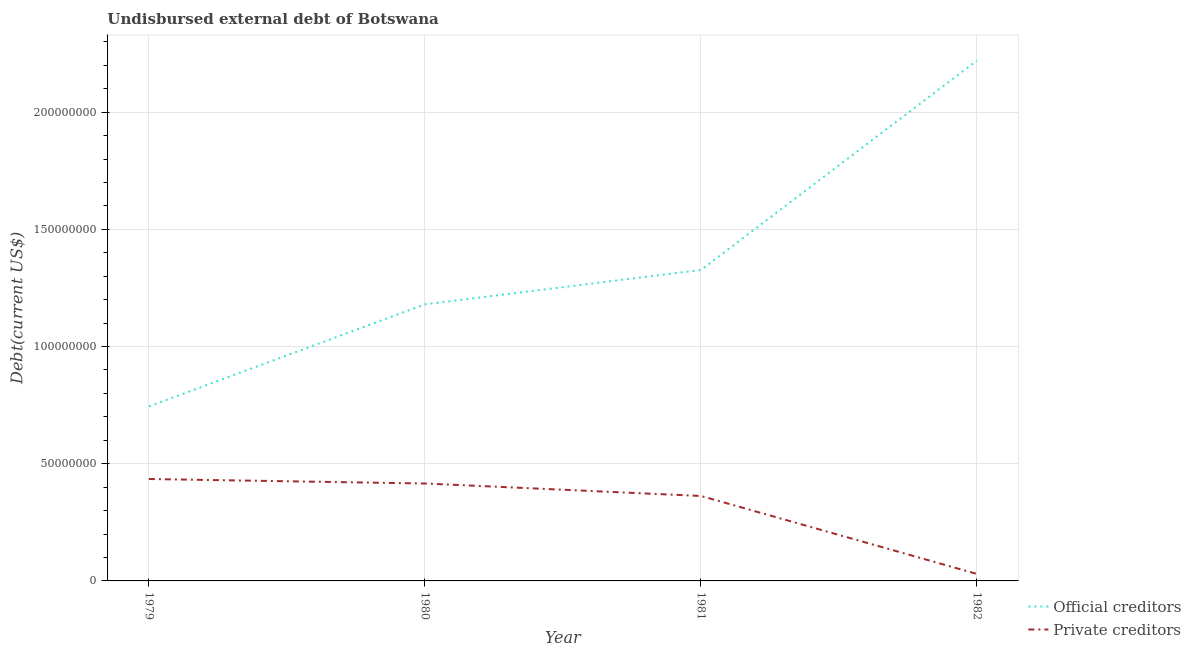Is the number of lines equal to the number of legend labels?
Your answer should be very brief. Yes. What is the undisbursed external debt of private creditors in 1981?
Ensure brevity in your answer.  3.62e+07. Across all years, what is the maximum undisbursed external debt of private creditors?
Provide a succinct answer. 4.35e+07. Across all years, what is the minimum undisbursed external debt of official creditors?
Your response must be concise. 7.44e+07. In which year was the undisbursed external debt of official creditors maximum?
Provide a short and direct response. 1982. In which year was the undisbursed external debt of private creditors minimum?
Provide a succinct answer. 1982. What is the total undisbursed external debt of private creditors in the graph?
Your response must be concise. 1.24e+08. What is the difference between the undisbursed external debt of official creditors in 1980 and that in 1982?
Keep it short and to the point. -1.04e+08. What is the difference between the undisbursed external debt of private creditors in 1979 and the undisbursed external debt of official creditors in 1980?
Make the answer very short. -7.45e+07. What is the average undisbursed external debt of official creditors per year?
Give a very brief answer. 1.37e+08. In the year 1979, what is the difference between the undisbursed external debt of private creditors and undisbursed external debt of official creditors?
Provide a succinct answer. -3.10e+07. In how many years, is the undisbursed external debt of official creditors greater than 210000000 US$?
Make the answer very short. 1. What is the ratio of the undisbursed external debt of official creditors in 1980 to that in 1982?
Your response must be concise. 0.53. Is the difference between the undisbursed external debt of private creditors in 1979 and 1980 greater than the difference between the undisbursed external debt of official creditors in 1979 and 1980?
Ensure brevity in your answer.  Yes. What is the difference between the highest and the second highest undisbursed external debt of official creditors?
Your answer should be very brief. 8.94e+07. What is the difference between the highest and the lowest undisbursed external debt of private creditors?
Provide a succinct answer. 4.05e+07. In how many years, is the undisbursed external debt of private creditors greater than the average undisbursed external debt of private creditors taken over all years?
Keep it short and to the point. 3. Is the sum of the undisbursed external debt of official creditors in 1981 and 1982 greater than the maximum undisbursed external debt of private creditors across all years?
Ensure brevity in your answer.  Yes. Does the undisbursed external debt of official creditors monotonically increase over the years?
Your answer should be compact. Yes. How many years are there in the graph?
Offer a terse response. 4. What is the difference between two consecutive major ticks on the Y-axis?
Your answer should be compact. 5.00e+07. Does the graph contain any zero values?
Offer a very short reply. No. How many legend labels are there?
Make the answer very short. 2. How are the legend labels stacked?
Provide a succinct answer. Vertical. What is the title of the graph?
Offer a very short reply. Undisbursed external debt of Botswana. Does "Number of departures" appear as one of the legend labels in the graph?
Your answer should be very brief. No. What is the label or title of the X-axis?
Offer a very short reply. Year. What is the label or title of the Y-axis?
Offer a very short reply. Debt(current US$). What is the Debt(current US$) of Official creditors in 1979?
Your answer should be compact. 7.44e+07. What is the Debt(current US$) in Private creditors in 1979?
Provide a succinct answer. 4.35e+07. What is the Debt(current US$) of Official creditors in 1980?
Your answer should be very brief. 1.18e+08. What is the Debt(current US$) in Private creditors in 1980?
Keep it short and to the point. 4.16e+07. What is the Debt(current US$) in Official creditors in 1981?
Offer a terse response. 1.33e+08. What is the Debt(current US$) of Private creditors in 1981?
Your answer should be compact. 3.62e+07. What is the Debt(current US$) in Official creditors in 1982?
Make the answer very short. 2.22e+08. What is the Debt(current US$) of Private creditors in 1982?
Your answer should be compact. 2.98e+06. Across all years, what is the maximum Debt(current US$) of Official creditors?
Give a very brief answer. 2.22e+08. Across all years, what is the maximum Debt(current US$) in Private creditors?
Provide a succinct answer. 4.35e+07. Across all years, what is the minimum Debt(current US$) of Official creditors?
Keep it short and to the point. 7.44e+07. Across all years, what is the minimum Debt(current US$) of Private creditors?
Make the answer very short. 2.98e+06. What is the total Debt(current US$) of Official creditors in the graph?
Ensure brevity in your answer.  5.47e+08. What is the total Debt(current US$) in Private creditors in the graph?
Provide a succinct answer. 1.24e+08. What is the difference between the Debt(current US$) of Official creditors in 1979 and that in 1980?
Provide a short and direct response. -4.36e+07. What is the difference between the Debt(current US$) of Private creditors in 1979 and that in 1980?
Make the answer very short. 1.92e+06. What is the difference between the Debt(current US$) in Official creditors in 1979 and that in 1981?
Ensure brevity in your answer.  -5.82e+07. What is the difference between the Debt(current US$) in Private creditors in 1979 and that in 1981?
Provide a short and direct response. 7.23e+06. What is the difference between the Debt(current US$) of Official creditors in 1979 and that in 1982?
Give a very brief answer. -1.48e+08. What is the difference between the Debt(current US$) in Private creditors in 1979 and that in 1982?
Provide a short and direct response. 4.05e+07. What is the difference between the Debt(current US$) of Official creditors in 1980 and that in 1981?
Give a very brief answer. -1.46e+07. What is the difference between the Debt(current US$) in Private creditors in 1980 and that in 1981?
Provide a succinct answer. 5.32e+06. What is the difference between the Debt(current US$) of Official creditors in 1980 and that in 1982?
Make the answer very short. -1.04e+08. What is the difference between the Debt(current US$) in Private creditors in 1980 and that in 1982?
Your answer should be very brief. 3.86e+07. What is the difference between the Debt(current US$) in Official creditors in 1981 and that in 1982?
Provide a short and direct response. -8.94e+07. What is the difference between the Debt(current US$) of Private creditors in 1981 and that in 1982?
Ensure brevity in your answer.  3.33e+07. What is the difference between the Debt(current US$) of Official creditors in 1979 and the Debt(current US$) of Private creditors in 1980?
Provide a short and direct response. 3.29e+07. What is the difference between the Debt(current US$) in Official creditors in 1979 and the Debt(current US$) in Private creditors in 1981?
Give a very brief answer. 3.82e+07. What is the difference between the Debt(current US$) of Official creditors in 1979 and the Debt(current US$) of Private creditors in 1982?
Your answer should be very brief. 7.15e+07. What is the difference between the Debt(current US$) of Official creditors in 1980 and the Debt(current US$) of Private creditors in 1981?
Provide a short and direct response. 8.18e+07. What is the difference between the Debt(current US$) in Official creditors in 1980 and the Debt(current US$) in Private creditors in 1982?
Your answer should be compact. 1.15e+08. What is the difference between the Debt(current US$) of Official creditors in 1981 and the Debt(current US$) of Private creditors in 1982?
Your answer should be compact. 1.30e+08. What is the average Debt(current US$) of Official creditors per year?
Provide a succinct answer. 1.37e+08. What is the average Debt(current US$) in Private creditors per year?
Offer a terse response. 3.11e+07. In the year 1979, what is the difference between the Debt(current US$) of Official creditors and Debt(current US$) of Private creditors?
Give a very brief answer. 3.10e+07. In the year 1980, what is the difference between the Debt(current US$) in Official creditors and Debt(current US$) in Private creditors?
Keep it short and to the point. 7.64e+07. In the year 1981, what is the difference between the Debt(current US$) in Official creditors and Debt(current US$) in Private creditors?
Offer a very short reply. 9.64e+07. In the year 1982, what is the difference between the Debt(current US$) of Official creditors and Debt(current US$) of Private creditors?
Provide a short and direct response. 2.19e+08. What is the ratio of the Debt(current US$) of Official creditors in 1979 to that in 1980?
Your answer should be very brief. 0.63. What is the ratio of the Debt(current US$) in Private creditors in 1979 to that in 1980?
Give a very brief answer. 1.05. What is the ratio of the Debt(current US$) in Official creditors in 1979 to that in 1981?
Your answer should be very brief. 0.56. What is the ratio of the Debt(current US$) in Private creditors in 1979 to that in 1981?
Offer a very short reply. 1.2. What is the ratio of the Debt(current US$) of Official creditors in 1979 to that in 1982?
Provide a short and direct response. 0.34. What is the ratio of the Debt(current US$) in Private creditors in 1979 to that in 1982?
Your answer should be very brief. 14.6. What is the ratio of the Debt(current US$) in Official creditors in 1980 to that in 1981?
Offer a very short reply. 0.89. What is the ratio of the Debt(current US$) of Private creditors in 1980 to that in 1981?
Provide a short and direct response. 1.15. What is the ratio of the Debt(current US$) in Official creditors in 1980 to that in 1982?
Offer a very short reply. 0.53. What is the ratio of the Debt(current US$) of Private creditors in 1980 to that in 1982?
Your response must be concise. 13.96. What is the ratio of the Debt(current US$) in Official creditors in 1981 to that in 1982?
Offer a terse response. 0.6. What is the ratio of the Debt(current US$) in Private creditors in 1981 to that in 1982?
Ensure brevity in your answer.  12.17. What is the difference between the highest and the second highest Debt(current US$) of Official creditors?
Keep it short and to the point. 8.94e+07. What is the difference between the highest and the second highest Debt(current US$) in Private creditors?
Keep it short and to the point. 1.92e+06. What is the difference between the highest and the lowest Debt(current US$) of Official creditors?
Your response must be concise. 1.48e+08. What is the difference between the highest and the lowest Debt(current US$) in Private creditors?
Your answer should be very brief. 4.05e+07. 